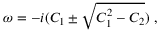<formula> <loc_0><loc_0><loc_500><loc_500>\omega = - i ( C _ { 1 } \pm \sqrt { C _ { 1 } ^ { 2 } - C _ { 2 } } ) \ ,</formula> 